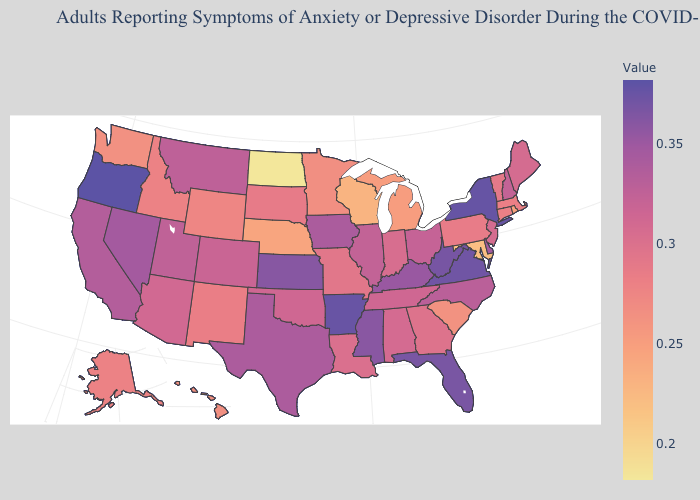Among the states that border South Carolina , does Georgia have the highest value?
Quick response, please. No. Among the states that border Tennessee , which have the highest value?
Be succinct. Arkansas. Among the states that border Montana , which have the lowest value?
Write a very short answer. North Dakota. Does Washington have a lower value than Nevada?
Keep it brief. Yes. Which states have the lowest value in the USA?
Concise answer only. North Dakota. Does Oregon have the highest value in the USA?
Be succinct. Yes. 